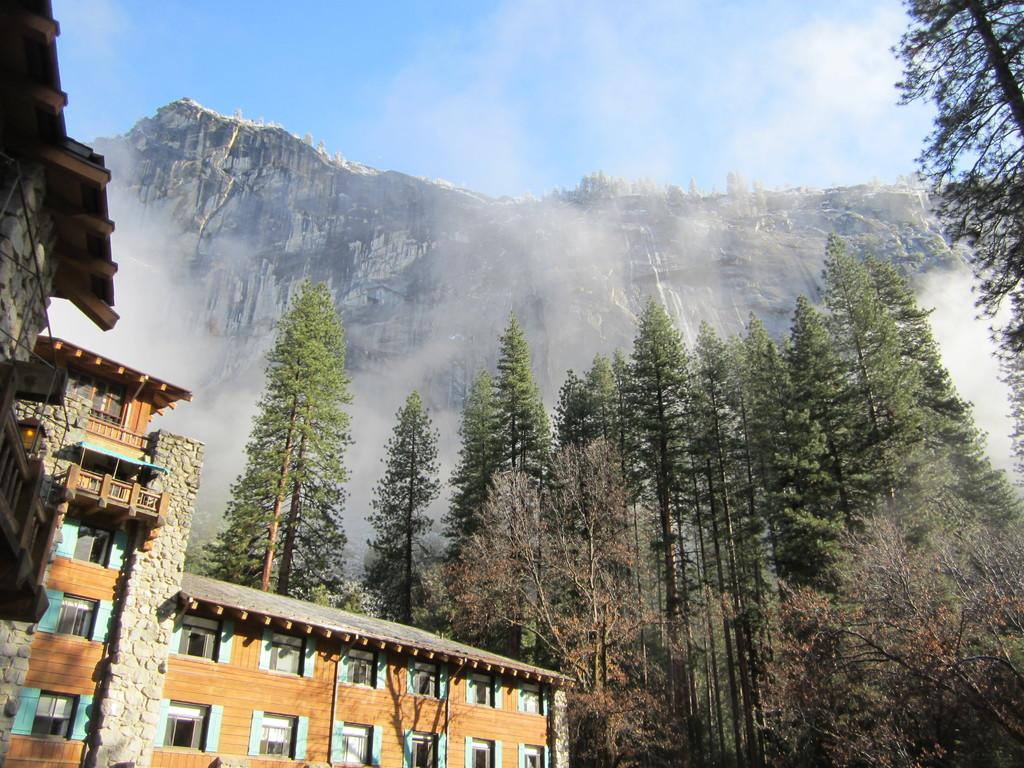What type of structures can be seen in the image? There are buildings in the image. What type of vegetation is present in the image? There are trees in the image. What type of natural landform can be seen in the image? There are mountains in the image. What is visible in the background of the image? The sky is visible in the image. How many seeds are present in the image? There is no mention of seeds in the image, so it is impossible to determine their number. What type of animals can be seen interacting with the trees in the image? There are no animals present in the image, so it is impossible to determine which type might be interacting with the trees. 